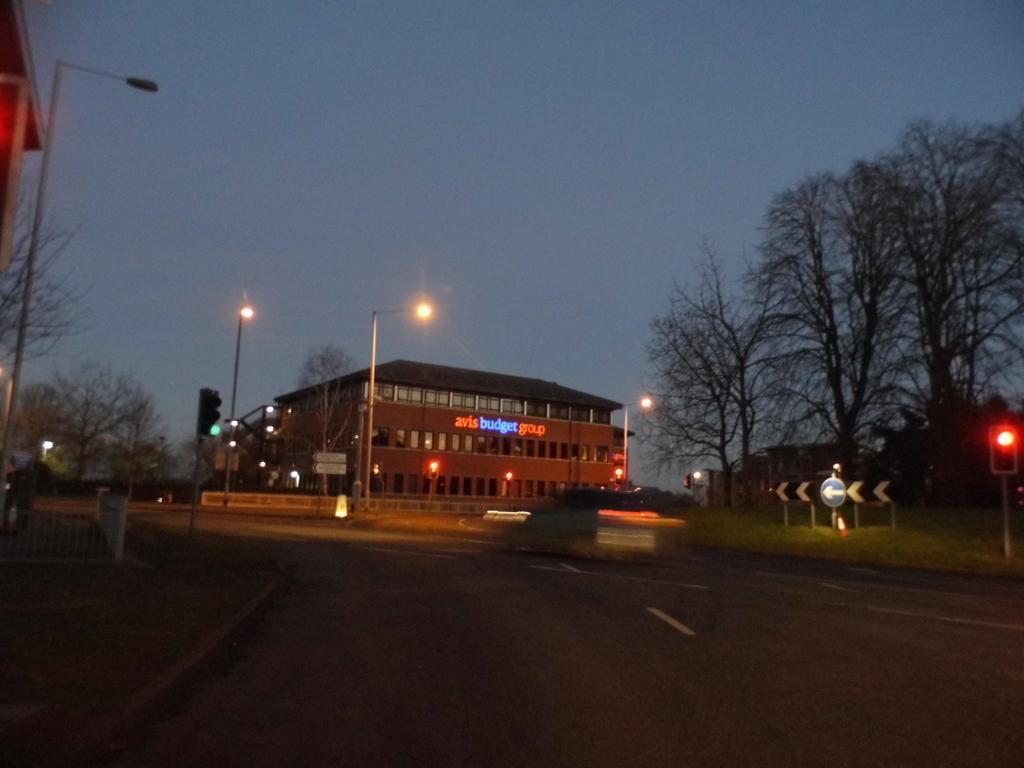In one or two sentences, can you explain what this image depicts? In this image, we can see buildings, trees, lights, poles, boards and we can see a fence. At the top, there is sky and at the bottom, there is a road. 